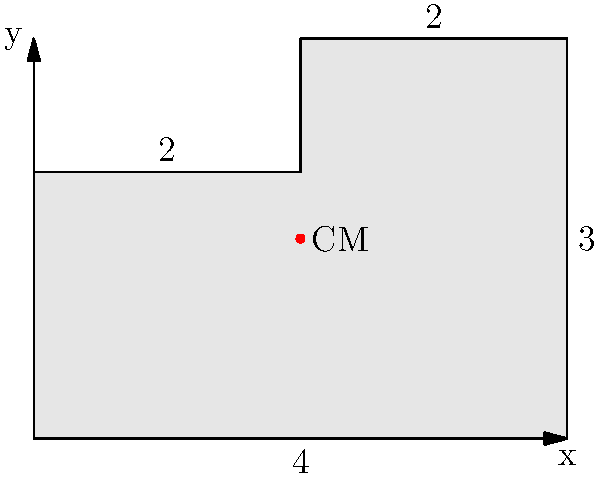An irregular L-shaped object is shown in the figure. The object is made of a uniform material and has a constant thickness. Determine the coordinates of its center of mass (CM). All dimensions are in meters. To find the center of mass of this irregular shape, we can divide it into two rectangles and use the composite body method. Let's follow these steps:

1. Divide the L-shape into two rectangles:
   Rectangle 1: 4m x 2m
   Rectangle 2: 2m x 1m

2. Calculate the area of each rectangle:
   $A_1 = 4 \times 2 = 8$ m²
   $A_2 = 2 \times 1 = 2$ m²

3. Find the centroid of each rectangle:
   Rectangle 1: $(x_1, y_1) = (2, 1)$
   Rectangle 2: $(x_2, y_2) = (3, 2.5)$

4. Calculate the total area:
   $A_{total} = A_1 + A_2 = 8 + 2 = 10$ m²

5. Use the centroid formula for composite bodies:
   $x_{CM} = \frac{A_1x_1 + A_2x_2}{A_{total}} = \frac{8(2) + 2(3)}{10} = \frac{16 + 6}{10} = 2.2$ m

   $y_{CM} = \frac{A_1y_1 + A_2y_2}{A_{total}} = \frac{8(1) + 2(2.5)}{10} = \frac{8 + 5}{10} = 1.3$ m

Therefore, the center of mass is located at (2.2 m, 1.3 m) from the origin.
Answer: (2.2 m, 1.3 m) 